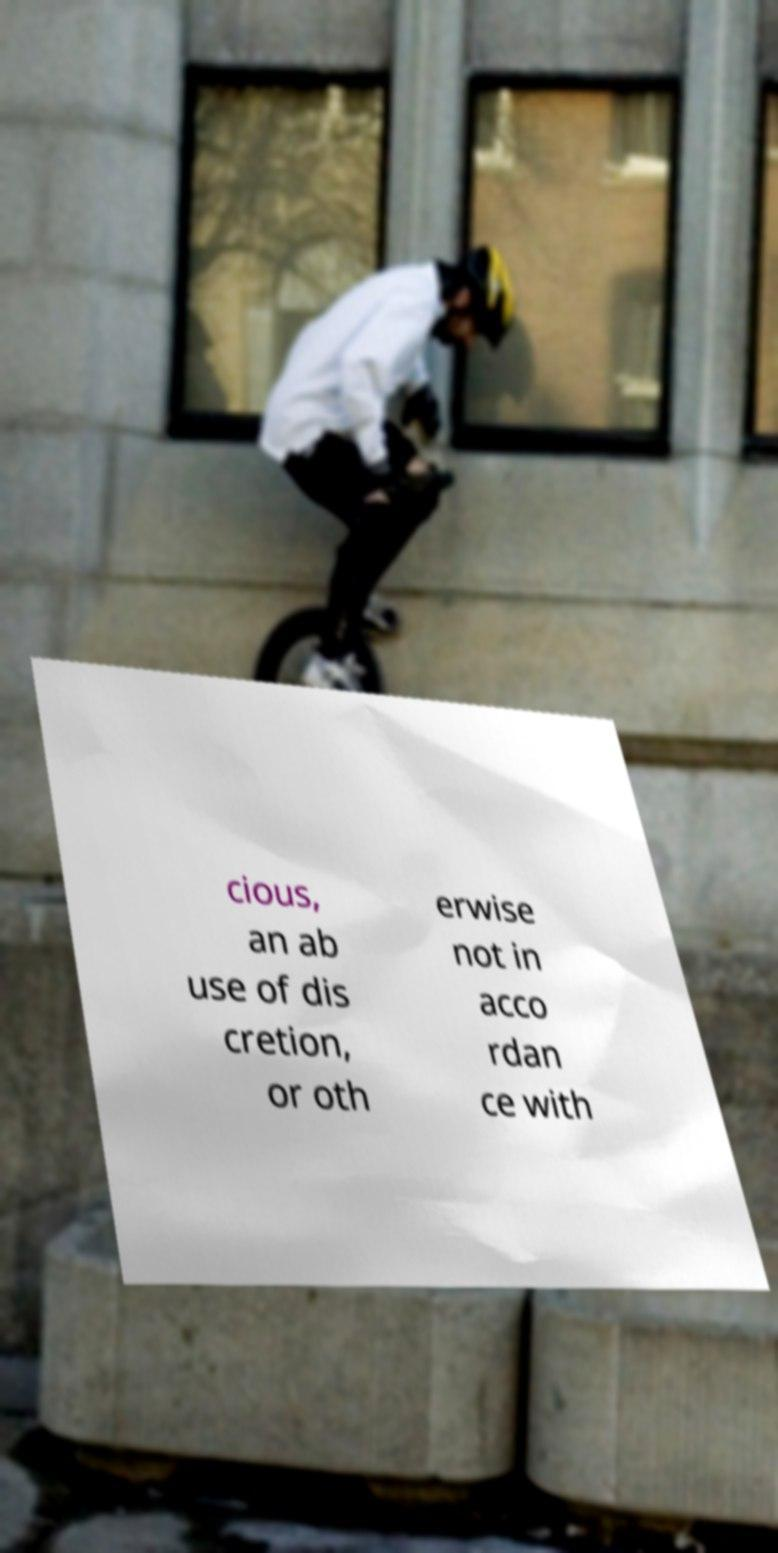Can you accurately transcribe the text from the provided image for me? cious, an ab use of dis cretion, or oth erwise not in acco rdan ce with 